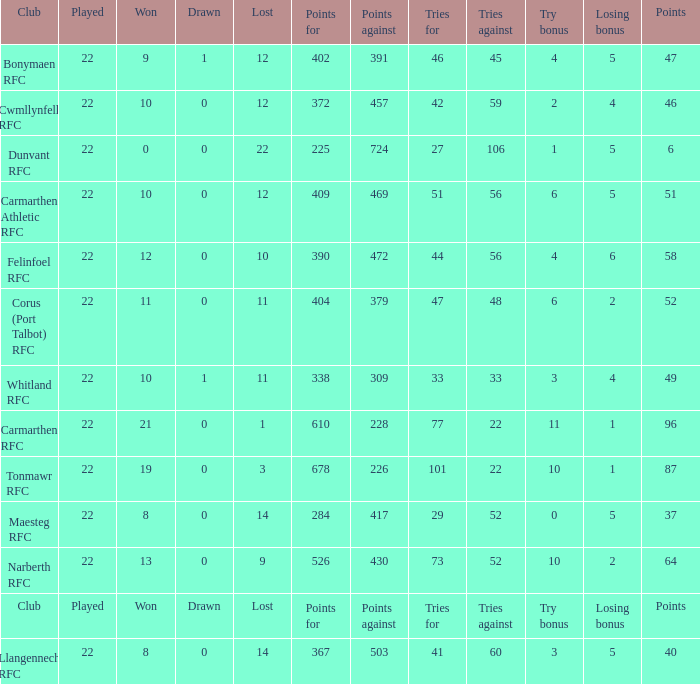Name the losing bonus for 27 5.0. 